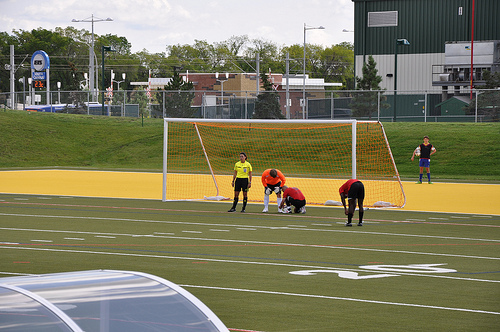<image>
Can you confirm if the woman is in front of the goal post? Yes. The woman is positioned in front of the goal post, appearing closer to the camera viewpoint. Is the player in front of the goal point? Yes. The player is positioned in front of the goal point, appearing closer to the camera viewpoint. 